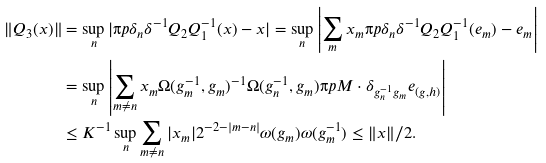<formula> <loc_0><loc_0><loc_500><loc_500>\| Q _ { 3 } ( x ) \| & = \sup _ { n } | \i p { \delta _ { n } } { \delta ^ { - 1 } Q _ { 2 } Q _ { 1 } ^ { - 1 } ( x ) - x } | = \sup _ { n } \left | \sum _ { m } x _ { m } \i p { \delta _ { n } } { \delta ^ { - 1 } Q _ { 2 } Q _ { 1 } ^ { - 1 } ( e _ { m } ) - e _ { m } } \right | \\ & = \sup _ { n } \left | \sum _ { m \not = n } x _ { m } \Omega ( g _ { m } ^ { - 1 } , g _ { m } ) ^ { - 1 } \Omega ( g _ { n } ^ { - 1 } , g _ { m } ) \i p { M \cdot \delta _ { g _ { n } ^ { - 1 } g _ { m } } } { e _ { ( g , h ) } } \right | \\ & \leq K ^ { - 1 } \sup _ { n } \sum _ { m \not = n } | x _ { m } | 2 ^ { - 2 - | m - n | } \omega ( g _ { m } ) \omega ( g _ { m } ^ { - 1 } ) \leq \| x \| / 2 .</formula> 